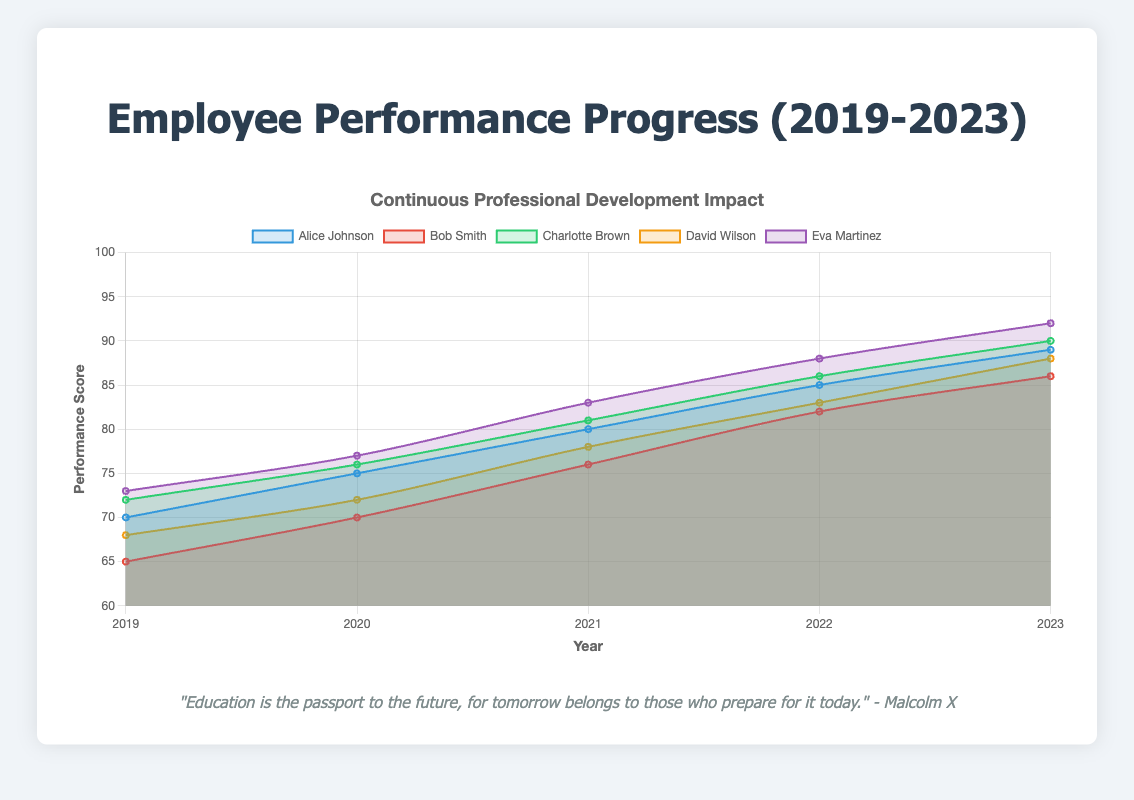What is the average performance score of Eva Martinez over the years 2019 to 2023? To calculate the average performance score of Eva Martinez, sum up her yearly scores: 73 (2019) + 77 (2020) + 83 (2021) + 88 (2022) + 92 (2023) = 413. Divide this sum by the number of years (5): 413 / 5 = 82.6
Answer: 82.6 Who has the highest performance score in 2023? In 2023, we need to compare the performance scores of each employee: Alice Johnson (89), Bob Smith (86), Charlotte Brown (90), David Wilson (88), Eva Martinez (92). Eva Martinez has the highest score.
Answer: Eva Martinez Which employee showed the greatest improvement in performance score from 2019 to 2023? Calculate the difference in scores for each employee: Alice Johnson (89 - 70 = 19), Bob Smith (86 - 65 = 21), Charlotte Brown (90 - 72 = 18), David Wilson (88 - 68 = 20), Eva Martinez (92 - 73 = 19). Bob Smith showed the greatest improvement.
Answer: Bob Smith What is the total performance score of David Wilson over the years 2019 to 2023? Sum up the yearly scores of David Wilson: 68 (2019) + 72 (2020) + 78 (2021) + 83 (2022) + 88 (2023) = 389
Answer: 389 How did Charlotte Brown's performance change from 2019 to 2022? Compare Charlotte Brown's scores in 2019 and 2022: 72 (2019) to 86 (2022). Her performance increased by 86 - 72 = 14 points.
Answer: Increased by 14 points Which two employees had equal performance scores in any given year? Compare the yearly scores of all employees year by year. In 2023, Bob Smith and David Wilson both had a performance score of 88.
Answer: Bob Smith and David Wilson in 2023 What is the difference between the highest and lowest performance scores in 2021? Identify the scores for 2021: Alice Johnson (80), Bob Smith (76), Charlotte Brown (81), David Wilson (78), Eva Martinez (83). The highest is 83 and the lowest is 76. Difference: 83 - 76 = 7
Answer: 7 Which employee's performance showed a consistent increase every year from 2019 to 2023? Review each employee's yearly scores to determine if they consistently increased each year. Alice Johnson (70, 75, 80, 85, 89), Bob Smith (65, 70, 76, 82, 86), Charlotte Brown (72, 76, 81, 86, 90), David Wilson (68, 72, 78, 83, 88), Eva Martinez (73, 77, 83, 88, 92). All employees showed a consistent increase.
Answer: All employees What was Bob Smith's annual performance improvement from 2019 to 2020? Calculate the difference between Bob Smith's scores in 2019 and 2020: 70 (2020) - 65 (2019) = 5
Answer: 5 Which employee had the smallest performance increase from 2022 to 2023? Calculate the difference in scores for each employee between 2022 and 2023: Alice Johnson (89 - 85 = 4), Bob Smith (86 - 82 = 4), Charlotte Brown (90 - 86 = 4), David Wilson (88 - 83 = 5), Eva Martinez (92 - 88 = 4). Therefore, Alice Johnson, Bob Smith, and Charlotte Brown all had the smallest increase of 4 points.
Answer: Alice Johnson, Bob Smith, and Charlotte Brown 